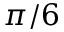<formula> <loc_0><loc_0><loc_500><loc_500>\pi / 6</formula> 